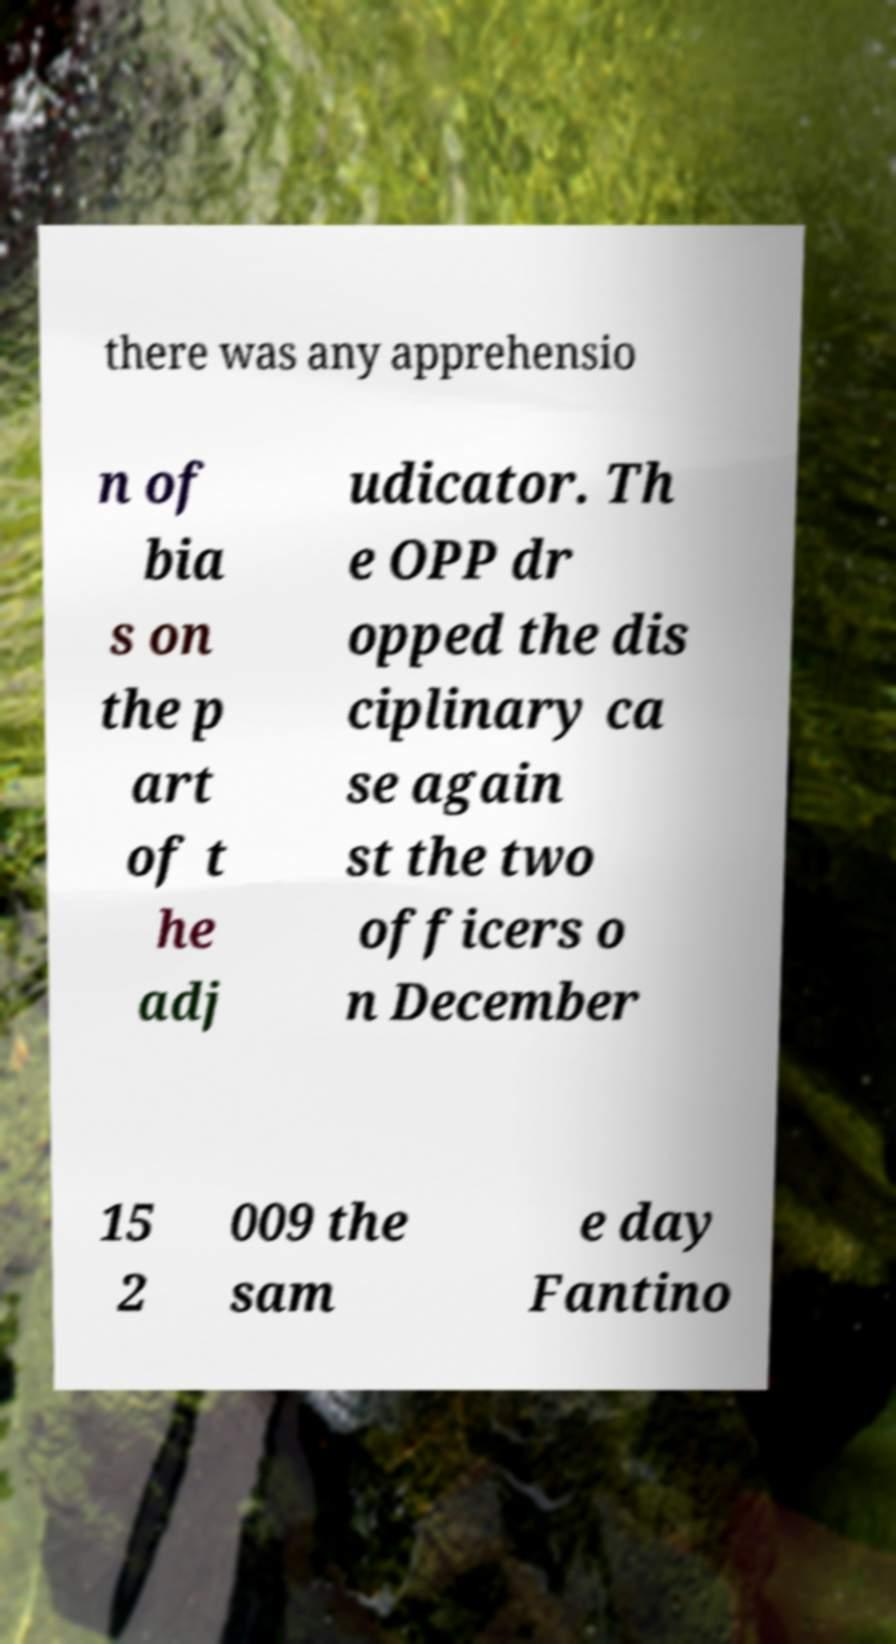What messages or text are displayed in this image? I need them in a readable, typed format. there was any apprehensio n of bia s on the p art of t he adj udicator. Th e OPP dr opped the dis ciplinary ca se again st the two officers o n December 15 2 009 the sam e day Fantino 